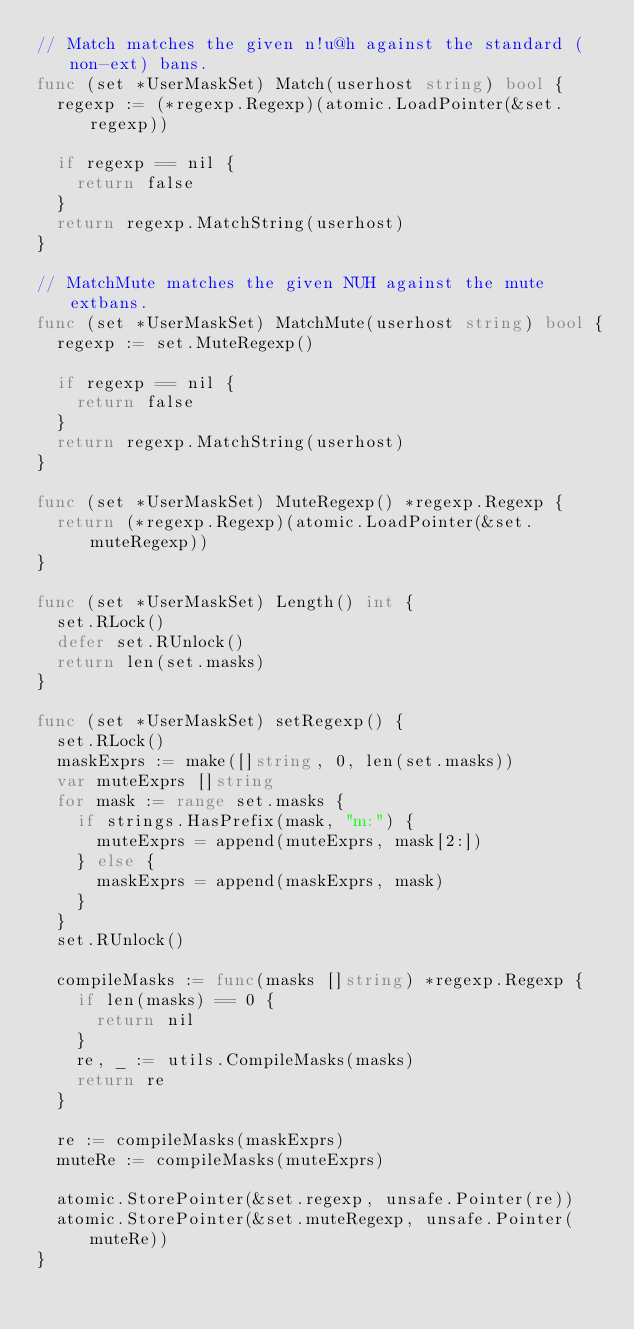Convert code to text. <code><loc_0><loc_0><loc_500><loc_500><_Go_>// Match matches the given n!u@h against the standard (non-ext) bans.
func (set *UserMaskSet) Match(userhost string) bool {
	regexp := (*regexp.Regexp)(atomic.LoadPointer(&set.regexp))

	if regexp == nil {
		return false
	}
	return regexp.MatchString(userhost)
}

// MatchMute matches the given NUH against the mute extbans.
func (set *UserMaskSet) MatchMute(userhost string) bool {
	regexp := set.MuteRegexp()

	if regexp == nil {
		return false
	}
	return regexp.MatchString(userhost)
}

func (set *UserMaskSet) MuteRegexp() *regexp.Regexp {
	return (*regexp.Regexp)(atomic.LoadPointer(&set.muteRegexp))
}

func (set *UserMaskSet) Length() int {
	set.RLock()
	defer set.RUnlock()
	return len(set.masks)
}

func (set *UserMaskSet) setRegexp() {
	set.RLock()
	maskExprs := make([]string, 0, len(set.masks))
	var muteExprs []string
	for mask := range set.masks {
		if strings.HasPrefix(mask, "m:") {
			muteExprs = append(muteExprs, mask[2:])
		} else {
			maskExprs = append(maskExprs, mask)
		}
	}
	set.RUnlock()

	compileMasks := func(masks []string) *regexp.Regexp {
		if len(masks) == 0 {
			return nil
		}
		re, _ := utils.CompileMasks(masks)
		return re
	}

	re := compileMasks(maskExprs)
	muteRe := compileMasks(muteExprs)

	atomic.StorePointer(&set.regexp, unsafe.Pointer(re))
	atomic.StorePointer(&set.muteRegexp, unsafe.Pointer(muteRe))
}
</code> 